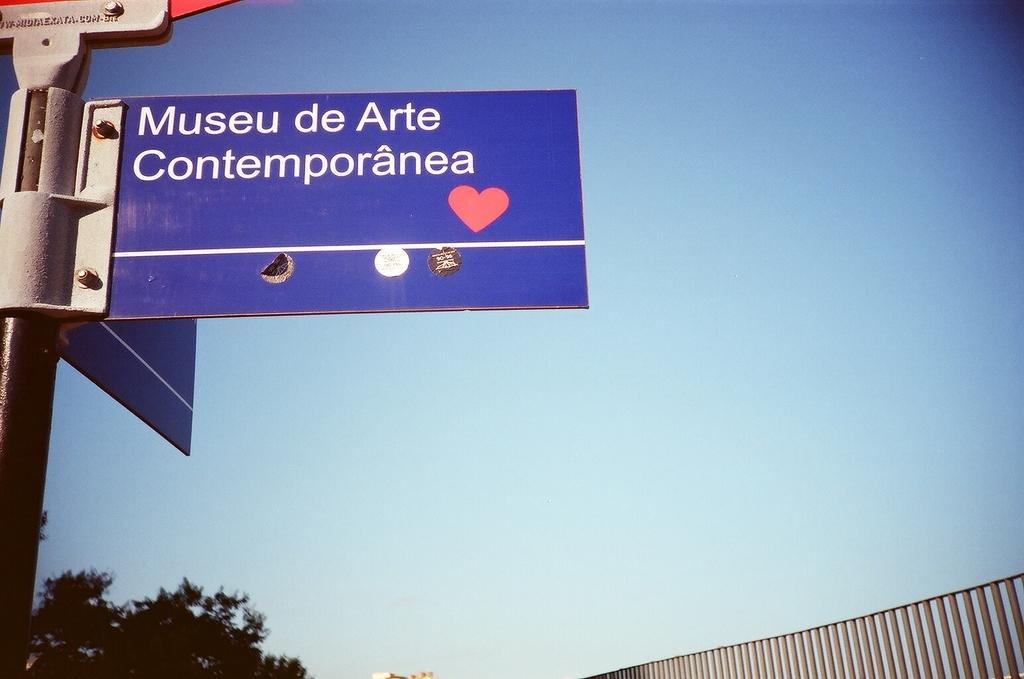<image>
Offer a succinct explanation of the picture presented. A blue sign that says Museu de Arte Contemporanea in front of a blue sky. 